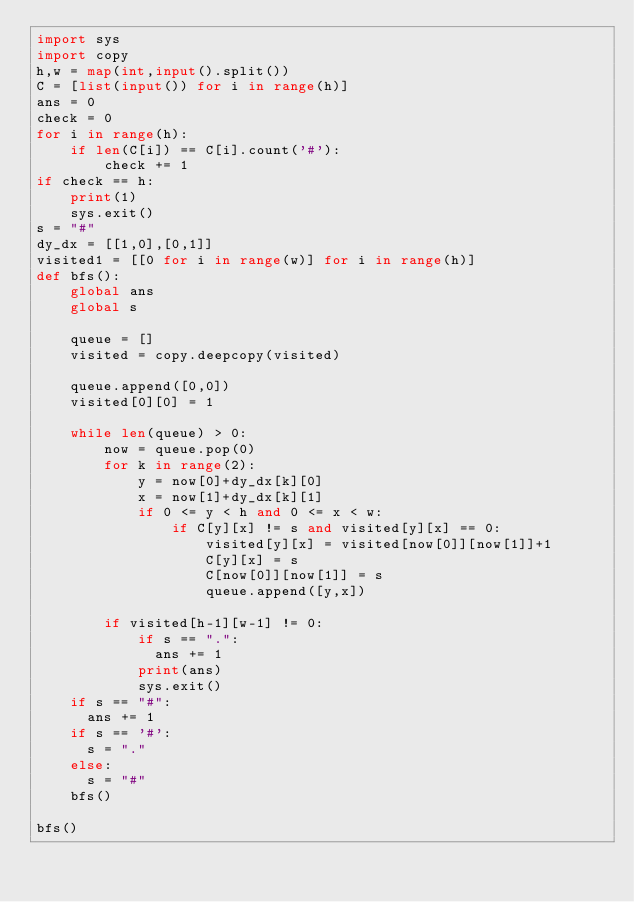Convert code to text. <code><loc_0><loc_0><loc_500><loc_500><_Python_>import sys
import copy
h,w = map(int,input().split())
C = [list(input()) for i in range(h)]
ans = 0
check = 0
for i in range(h):
    if len(C[i]) == C[i].count('#'):
        check += 1        
if check == h:
    print(1)
    sys.exit()
s = "#"   
dy_dx = [[1,0],[0,1]]
visited1 = [[0 for i in range(w)] for i in range(h)]
def bfs():
    global ans
    global s
    
    queue = []
    visited = copy.deepcopy(visited)

    queue.append([0,0])
    visited[0][0] = 1
  
    while len(queue) > 0:
        now = queue.pop(0)
        for k in range(2):
            y = now[0]+dy_dx[k][0]
            x = now[1]+dy_dx[k][1]
            if 0 <= y < h and 0 <= x < w:
                if C[y][x] != s and visited[y][x] == 0:
                    visited[y][x] = visited[now[0]][now[1]]+1
                    C[y][x] = s
                    C[now[0]][now[1]] = s
                    queue.append([y,x])
                    
        if visited[h-1][w-1] != 0:
            if s == ".":
              ans += 1
            print(ans)
            sys.exit()
    if s == "#":
      ans += 1
    if s == '#':
      s = "."
    else:
      s = "#"
    bfs()
        
bfs()</code> 